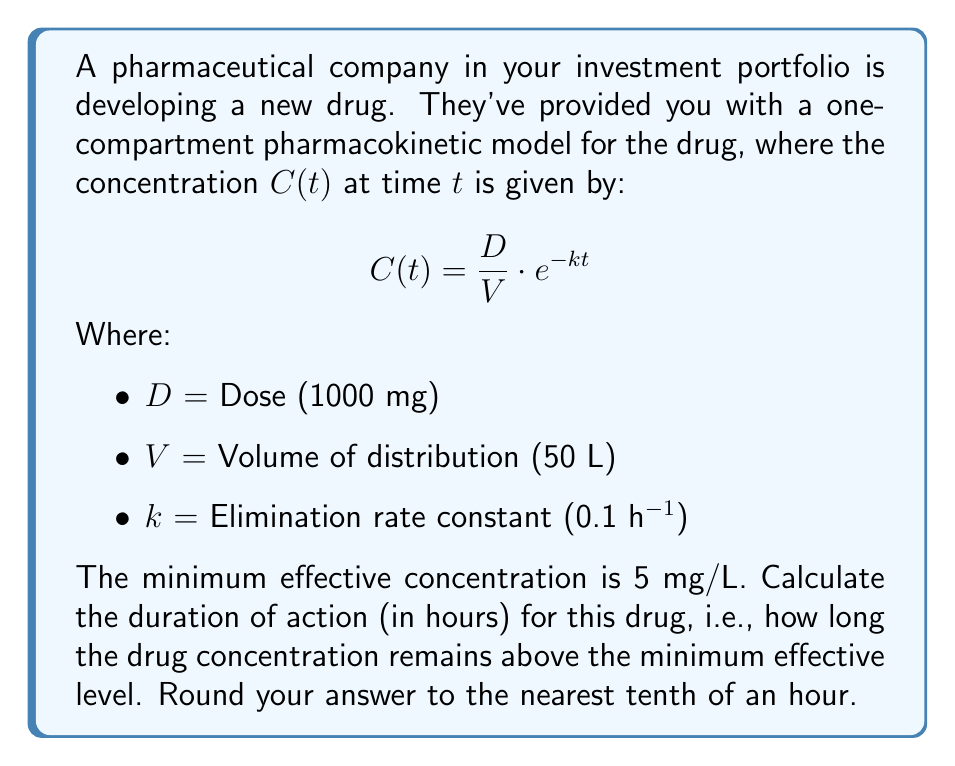Help me with this question. To solve this problem, we need to find the time $t$ when the concentration $C(t)$ equals the minimum effective concentration of 5 mg/L. We can do this by following these steps:

1. Set up the equation:
   $$5 = \frac{1000}{50} \cdot e^{-0.1t}$$

2. Simplify the left side of the equation:
   $$5 = 20 \cdot e^{-0.1t}$$

3. Divide both sides by 20:
   $$0.25 = e^{-0.1t}$$

4. Take the natural logarithm of both sides:
   $$\ln(0.25) = -0.1t$$

5. Solve for $t$:
   $$t = \frac{\ln(0.25)}{-0.1}$$

6. Calculate the result:
   $$t = \frac{-1.3862943611198906}{-0.1} \approx 13.86 \text{ hours}$$

7. Round to the nearest tenth:
   $$t \approx 13.9 \text{ hours}$$

This means the drug concentration remains above the minimum effective level for approximately 13.9 hours.
Answer: 13.9 hours 